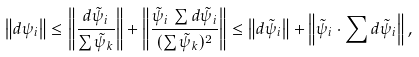Convert formula to latex. <formula><loc_0><loc_0><loc_500><loc_500>\left \| d \psi _ { i } \right \| \leq \left \| \frac { d \tilde { \psi } _ { i } } { \sum \tilde { \psi } _ { k } } \right \| + \left \| \frac { \tilde { \psi } _ { i } \, \sum d \tilde { \psi } _ { i } } { ( \sum \tilde { \psi } _ { k } ) ^ { 2 } } \right \| \leq \left \| d \tilde { \psi } _ { i } \right \| + \left \| \tilde { \psi } _ { i } \cdot \sum d \tilde { \psi } _ { i } \right \| ,</formula> 